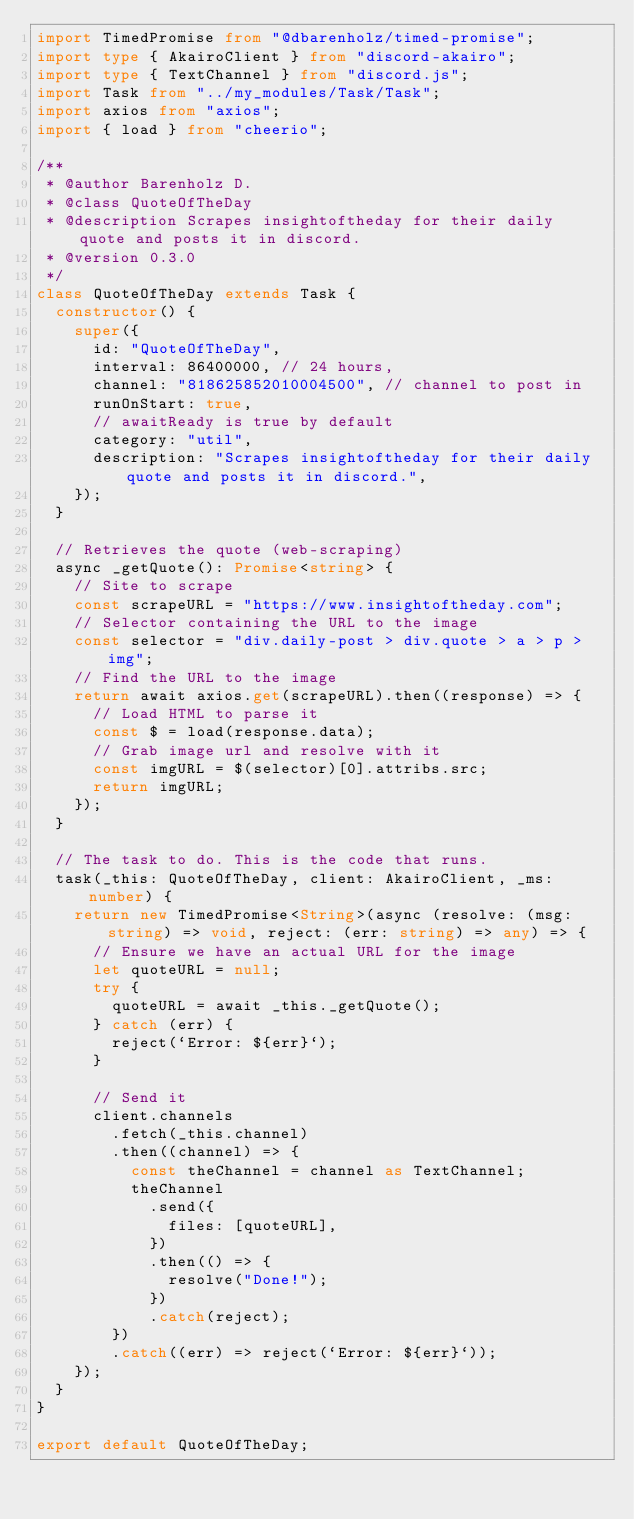<code> <loc_0><loc_0><loc_500><loc_500><_TypeScript_>import TimedPromise from "@dbarenholz/timed-promise";
import type { AkairoClient } from "discord-akairo";
import type { TextChannel } from "discord.js";
import Task from "../my_modules/Task/Task";
import axios from "axios";
import { load } from "cheerio";

/**
 * @author Barenholz D.
 * @class QuoteOfTheDay
 * @description Scrapes insightoftheday for their daily quote and posts it in discord.
 * @version 0.3.0
 */
class QuoteOfTheDay extends Task {
  constructor() {
    super({
      id: "QuoteOfTheDay",
      interval: 86400000, // 24 hours,
      channel: "818625852010004500", // channel to post in
      runOnStart: true,
      // awaitReady is true by default
      category: "util",
      description: "Scrapes insightoftheday for their daily quote and posts it in discord.",
    });
  }

  // Retrieves the quote (web-scraping)
  async _getQuote(): Promise<string> {
    // Site to scrape
    const scrapeURL = "https://www.insightoftheday.com";
    // Selector containing the URL to the image
    const selector = "div.daily-post > div.quote > a > p > img";
    // Find the URL to the image
    return await axios.get(scrapeURL).then((response) => {
      // Load HTML to parse it
      const $ = load(response.data);
      // Grab image url and resolve with it
      const imgURL = $(selector)[0].attribs.src;
      return imgURL;
    });
  }

  // The task to do. This is the code that runs.
  task(_this: QuoteOfTheDay, client: AkairoClient, _ms: number) {
    return new TimedPromise<String>(async (resolve: (msg: string) => void, reject: (err: string) => any) => {
      // Ensure we have an actual URL for the image
      let quoteURL = null;
      try {
        quoteURL = await _this._getQuote();
      } catch (err) {
        reject(`Error: ${err}`);
      }

      // Send it
      client.channels
        .fetch(_this.channel)
        .then((channel) => {
          const theChannel = channel as TextChannel;
          theChannel
            .send({
              files: [quoteURL],
            })
            .then(() => {
              resolve("Done!");
            })
            .catch(reject);
        })
        .catch((err) => reject(`Error: ${err}`));
    });
  }
}

export default QuoteOfTheDay;
</code> 